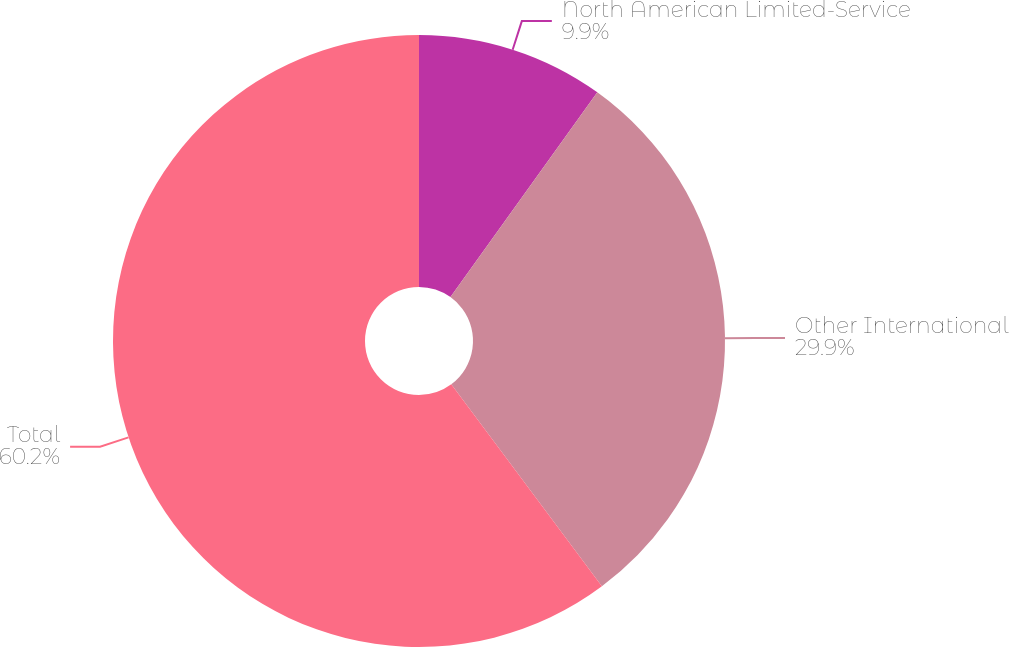Convert chart to OTSL. <chart><loc_0><loc_0><loc_500><loc_500><pie_chart><fcel>North American Limited-Service<fcel>Other International<fcel>Total<nl><fcel>9.9%<fcel>29.9%<fcel>60.19%<nl></chart> 